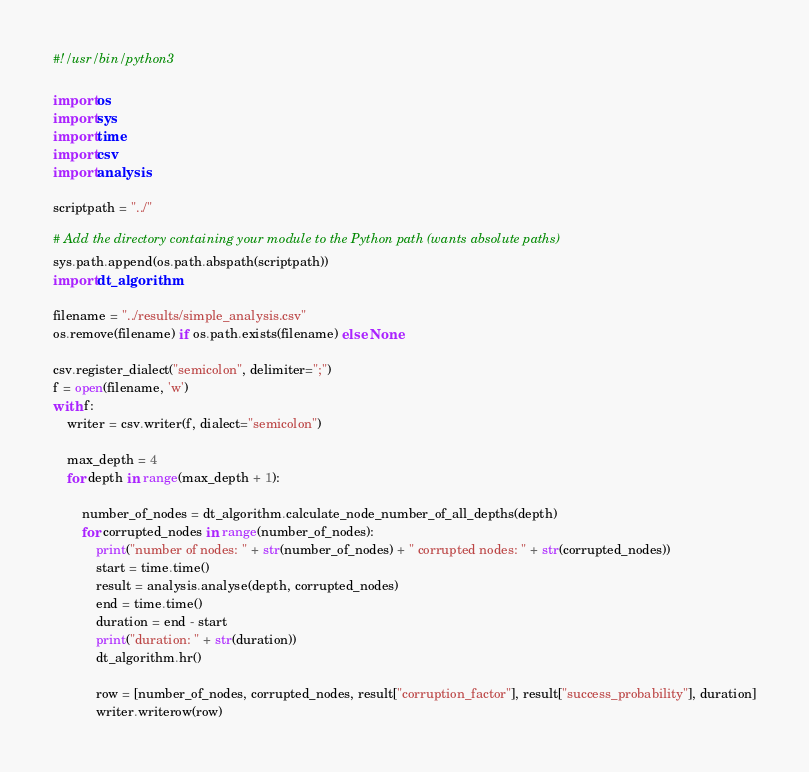Convert code to text. <code><loc_0><loc_0><loc_500><loc_500><_Python_>#!/usr/bin/python3

import os
import sys
import time
import csv
import analysis

scriptpath = "../"

# Add the directory containing your module to the Python path (wants absolute paths)
sys.path.append(os.path.abspath(scriptpath))
import dt_algorithm

filename = "../results/simple_analysis.csv"
os.remove(filename) if os.path.exists(filename) else None

csv.register_dialect("semicolon", delimiter=";")
f = open(filename, 'w')
with f:
    writer = csv.writer(f, dialect="semicolon")

    max_depth = 4
    for depth in range(max_depth + 1):

        number_of_nodes = dt_algorithm.calculate_node_number_of_all_depths(depth)
        for corrupted_nodes in range(number_of_nodes):
            print("number of nodes: " + str(number_of_nodes) + " corrupted nodes: " + str(corrupted_nodes))
            start = time.time()
            result = analysis.analyse(depth, corrupted_nodes)
            end = time.time()
            duration = end - start
            print("duration: " + str(duration))
            dt_algorithm.hr()

            row = [number_of_nodes, corrupted_nodes, result["corruption_factor"], result["success_probability"], duration]
            writer.writerow(row)
</code> 